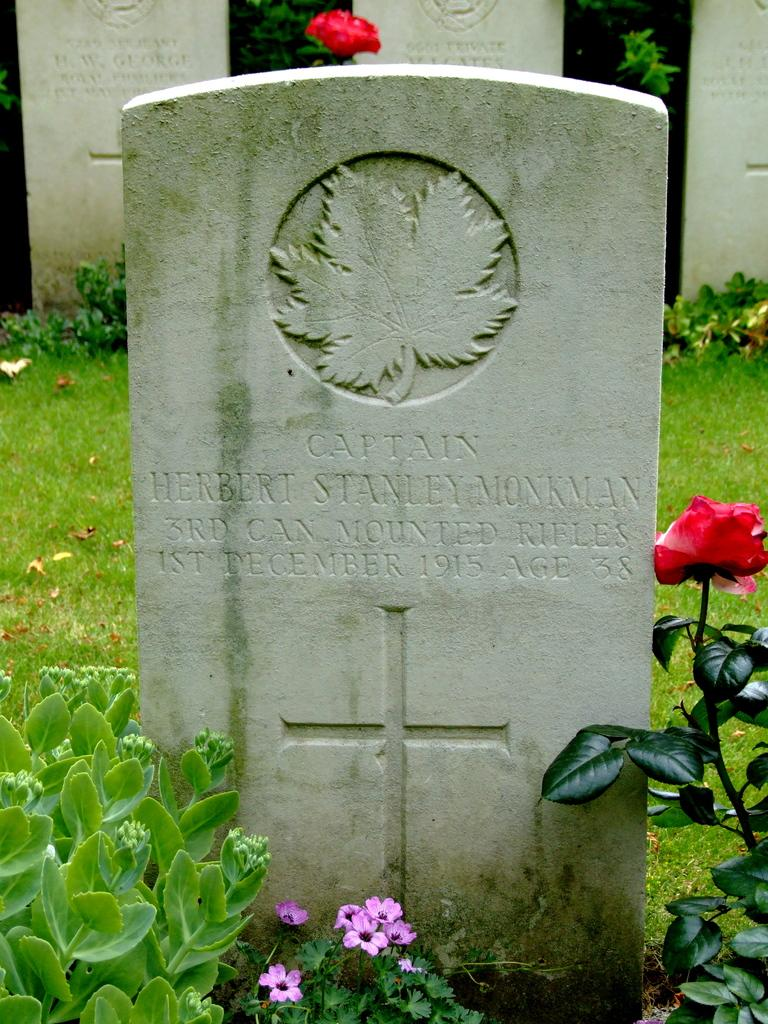What type of vegetation can be seen in the image? There are plants, grass, and flowers in the image. What are the memorial stones in the image used for? The memorial stones in the image are used to commemorate or remember someone or something. What is written on the memorial stones? Something is written on the memorial stones, but the specific text cannot be determined from the image. How is the land covered in the image? The land is covered with grass in the image. What type of trouble is the yam causing in the image? There is no yam present in the image, so it cannot be causing any trouble. 